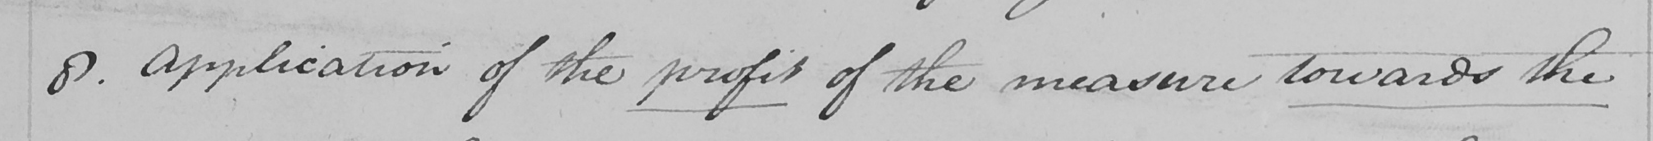What is written in this line of handwriting? 8 . Application of the profit of the measure towards the 